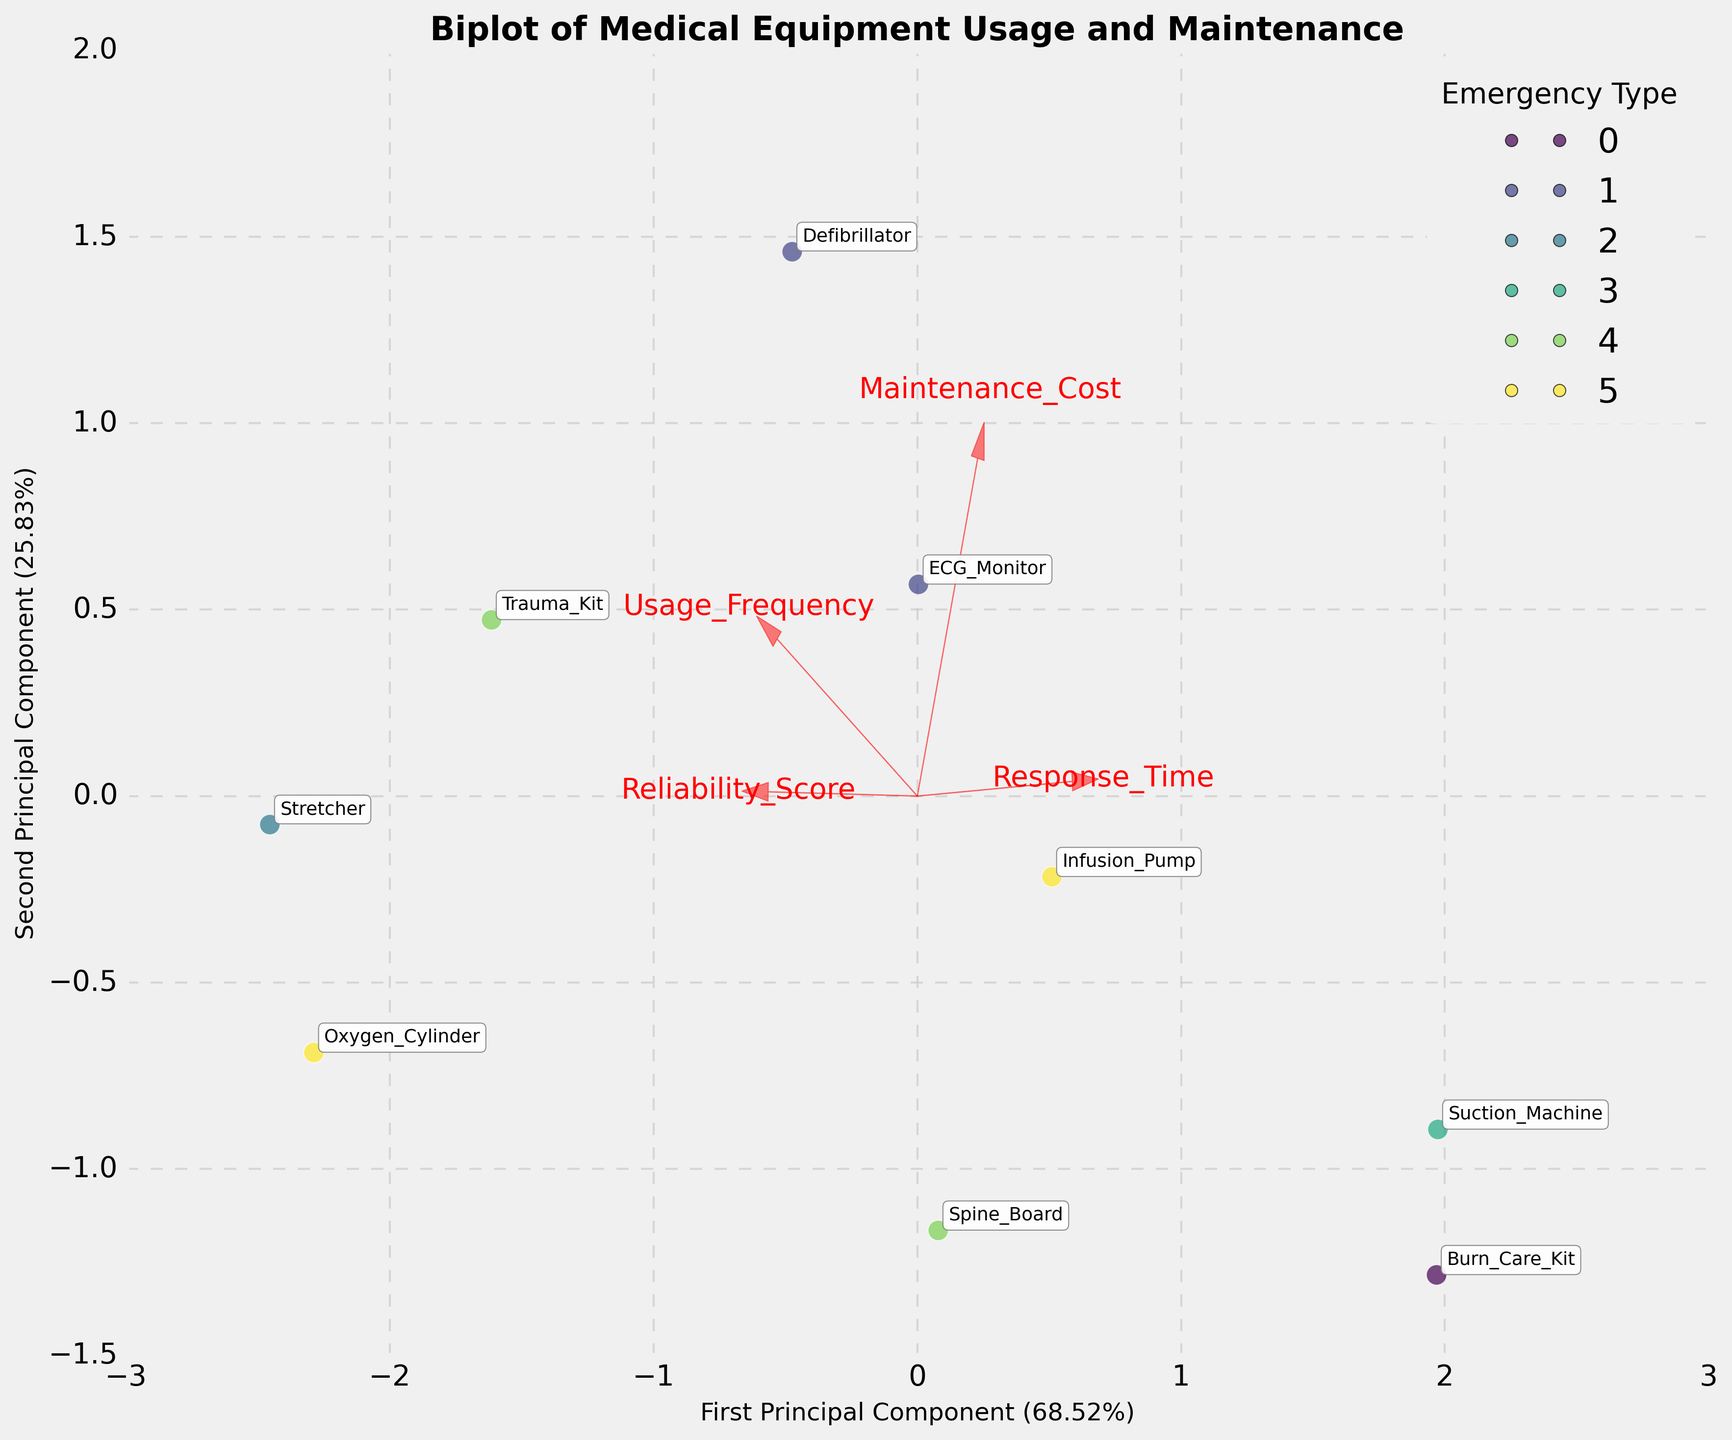How many principal components are displayed in the biplot? The figure displays two principal components on the X and Y axes, labeled respectively as the First Principal Component and the Second Principal Component.
Answer: 2 Which emergency type corresponds to equipment positioned at the top-right corner of the plot? The top-right corner of the plot shows equipment that clusters with the "Trauma" emergency type.
Answer: Trauma Which feature has the highest contribution along the first principal component? The arrows representing features show that "Usage Frequency" has the highest projection along the first principal component.
Answer: Usage Frequency Which piece of equipment has the lowest reliability score? The piece of equipment positioned closest to the direction of the arrow representing "Reliability Score" with the least value in the negative direction is the Burn Care Kit.
Answer: Burn Care Kit Which equipment has the smallest maintenance cost? By observing the plots in relation to the arrow labeled "Maintenance Cost," the Oxygen Cylinder seems to have the smallest maintenance cost due to its position being furthest in the negative direction along this feature.
Answer: Oxygen Cylinder Are the cardiac emergency equipment clustered together or spread out? The equipment associated with cardiac emergencies (Defibrillator and ECG Monitor) are fairly close to each other, indicating they are more clustered than spread out.
Answer: Clustered Which two emergency types are most closely located to each other in the plot? By inspecting the legend and the positioning of the clusters, "Cardiac" and "Various" emergency types are located closely to each other in the plot.
Answer: Cardiac and Various Is the Defibrillator associated with higher or lower usage frequency compared to the Ventilator? The Defibrillator is positioned further along the positive direction of the "Usage Frequency" axis compared to the Ventilator, indicating higher usage frequency.
Answer: Higher What component does spine board have the highest value in? The position of the Spine Board is highly aligned with the second principal component, indicating it has a high value predominantly along this component.
Answer: Second Principal Component Which feature contributes least to the second principal component? The relative length and direction of its arrow indicate that "Maintenance Cost" contributes least to the second principal component.
Answer: Maintenance Cost 